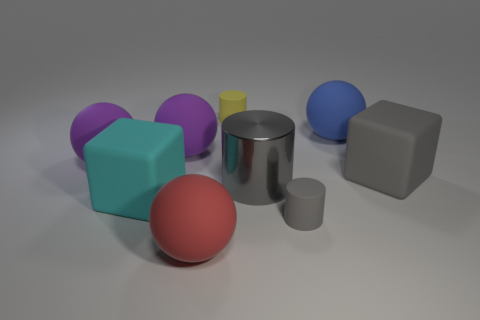There is a matte cube that is on the right side of the small cylinder in front of the cylinder behind the metal thing; what color is it?
Keep it short and to the point. Gray. The big cube in front of the gray rubber object behind the large gray metallic object is what color?
Give a very brief answer. Cyan. Are there more rubber things that are on the right side of the large blue ball than blue rubber objects that are in front of the large red thing?
Provide a short and direct response. Yes. Does the block that is right of the red object have the same material as the large block to the left of the red ball?
Keep it short and to the point. Yes. Are there any big matte blocks left of the big red object?
Ensure brevity in your answer.  Yes. How many purple things are either shiny cylinders or large matte blocks?
Provide a succinct answer. 0. Is the small yellow cylinder made of the same material as the large thing that is on the right side of the blue ball?
Give a very brief answer. Yes. What is the size of the blue object that is the same shape as the big red rubber object?
Provide a succinct answer. Large. What material is the small gray thing?
Your response must be concise. Rubber. What is the material of the big sphere that is right of the gray rubber object that is in front of the rubber cube to the left of the big red matte sphere?
Make the answer very short. Rubber. 